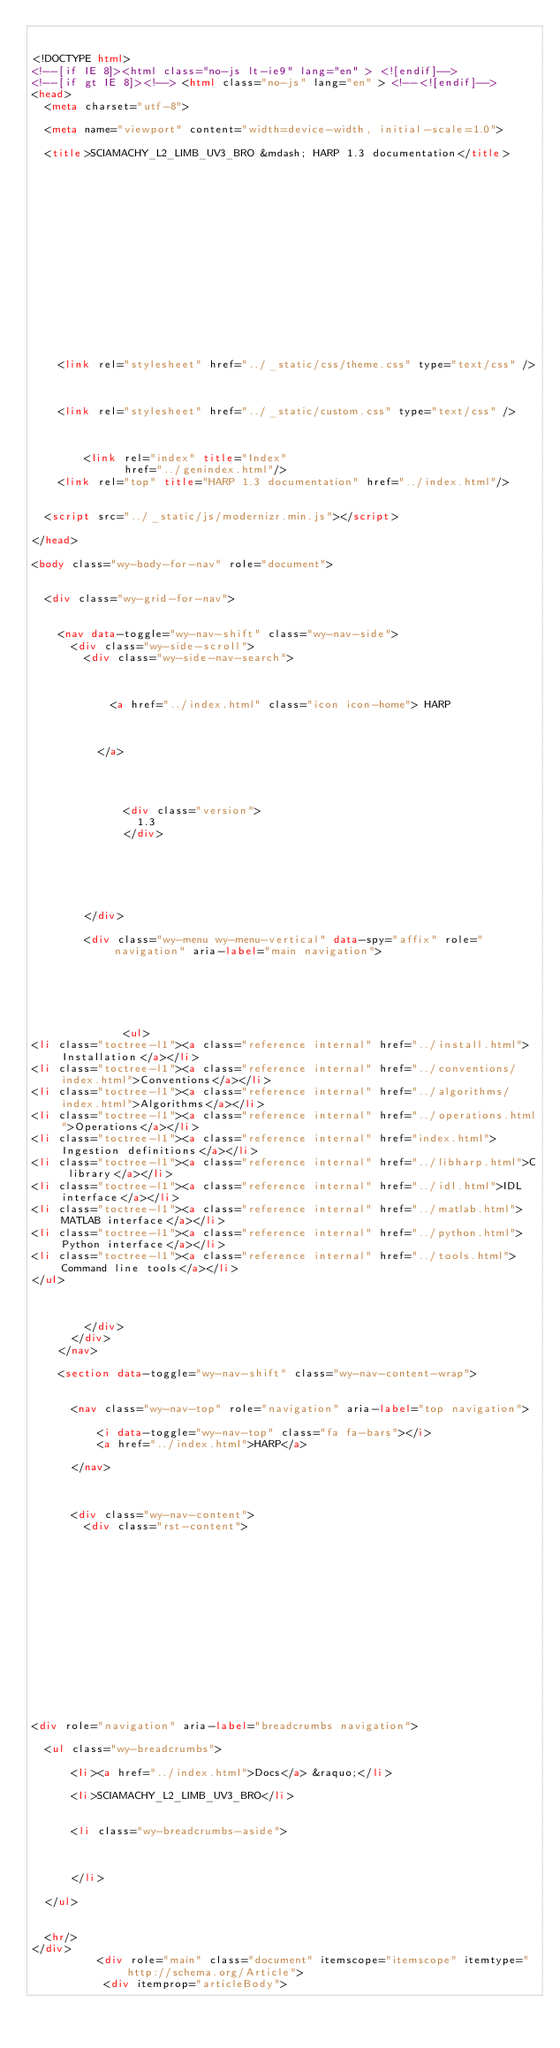<code> <loc_0><loc_0><loc_500><loc_500><_HTML_>

<!DOCTYPE html>
<!--[if IE 8]><html class="no-js lt-ie9" lang="en" > <![endif]-->
<!--[if gt IE 8]><!--> <html class="no-js" lang="en" > <!--<![endif]-->
<head>
  <meta charset="utf-8">
  
  <meta name="viewport" content="width=device-width, initial-scale=1.0">
  
  <title>SCIAMACHY_L2_LIMB_UV3_BRO &mdash; HARP 1.3 documentation</title>
  

  
  
  
  

  

  
  
    

  

  
  
    <link rel="stylesheet" href="../_static/css/theme.css" type="text/css" />
  

  
    <link rel="stylesheet" href="../_static/custom.css" type="text/css" />
  

  
        <link rel="index" title="Index"
              href="../genindex.html"/>
    <link rel="top" title="HARP 1.3 documentation" href="../index.html"/> 

  
  <script src="../_static/js/modernizr.min.js"></script>

</head>

<body class="wy-body-for-nav" role="document">

   
  <div class="wy-grid-for-nav">

    
    <nav data-toggle="wy-nav-shift" class="wy-nav-side">
      <div class="wy-side-scroll">
        <div class="wy-side-nav-search">
          

          
            <a href="../index.html" class="icon icon-home"> HARP
          

          
          </a>

          
            
            
              <div class="version">
                1.3
              </div>
            
          

          

          
        </div>

        <div class="wy-menu wy-menu-vertical" data-spy="affix" role="navigation" aria-label="main navigation">
          
            
            
              
            
            
              <ul>
<li class="toctree-l1"><a class="reference internal" href="../install.html">Installation</a></li>
<li class="toctree-l1"><a class="reference internal" href="../conventions/index.html">Conventions</a></li>
<li class="toctree-l1"><a class="reference internal" href="../algorithms/index.html">Algorithms</a></li>
<li class="toctree-l1"><a class="reference internal" href="../operations.html">Operations</a></li>
<li class="toctree-l1"><a class="reference internal" href="index.html">Ingestion definitions</a></li>
<li class="toctree-l1"><a class="reference internal" href="../libharp.html">C library</a></li>
<li class="toctree-l1"><a class="reference internal" href="../idl.html">IDL interface</a></li>
<li class="toctree-l1"><a class="reference internal" href="../matlab.html">MATLAB interface</a></li>
<li class="toctree-l1"><a class="reference internal" href="../python.html">Python interface</a></li>
<li class="toctree-l1"><a class="reference internal" href="../tools.html">Command line tools</a></li>
</ul>

            
          
        </div>
      </div>
    </nav>

    <section data-toggle="wy-nav-shift" class="wy-nav-content-wrap">

      
      <nav class="wy-nav-top" role="navigation" aria-label="top navigation">
        
          <i data-toggle="wy-nav-top" class="fa fa-bars"></i>
          <a href="../index.html">HARP</a>
        
      </nav>


      
      <div class="wy-nav-content">
        <div class="rst-content">
          















<div role="navigation" aria-label="breadcrumbs navigation">

  <ul class="wy-breadcrumbs">
    
      <li><a href="../index.html">Docs</a> &raquo;</li>
        
      <li>SCIAMACHY_L2_LIMB_UV3_BRO</li>
    
    
      <li class="wy-breadcrumbs-aside">
        
            
        
      </li>
    
  </ul>

  
  <hr/>
</div>
          <div role="main" class="document" itemscope="itemscope" itemtype="http://schema.org/Article">
           <div itemprop="articleBody">
            </code> 